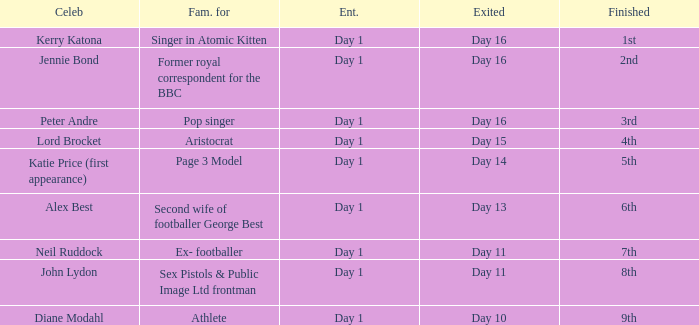Name the entered for famous for page 3 model Day 1. 